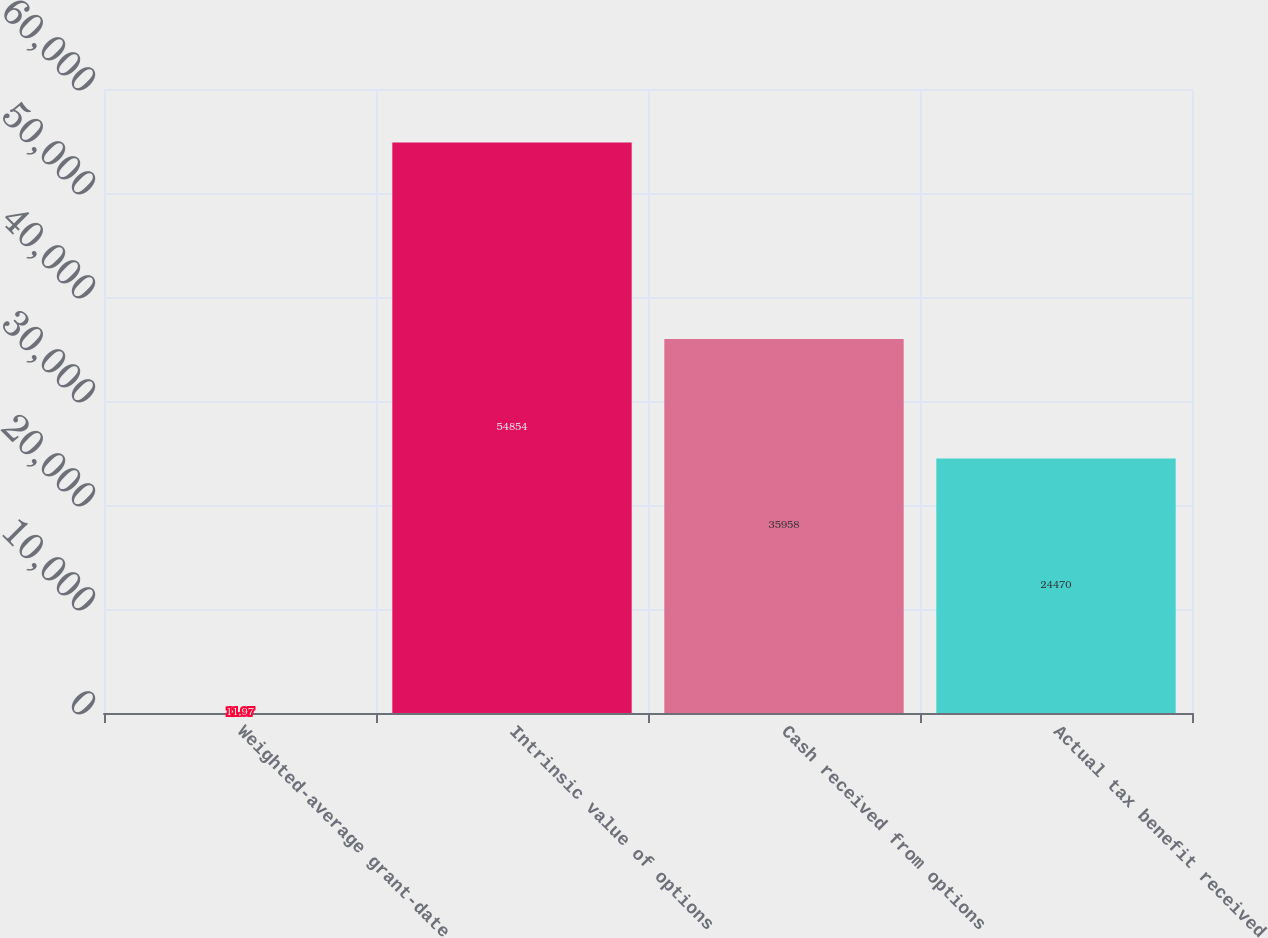Convert chart to OTSL. <chart><loc_0><loc_0><loc_500><loc_500><bar_chart><fcel>Weighted-average grant-date<fcel>Intrinsic value of options<fcel>Cash received from options<fcel>Actual tax benefit received<nl><fcel>11.97<fcel>54854<fcel>35958<fcel>24470<nl></chart> 